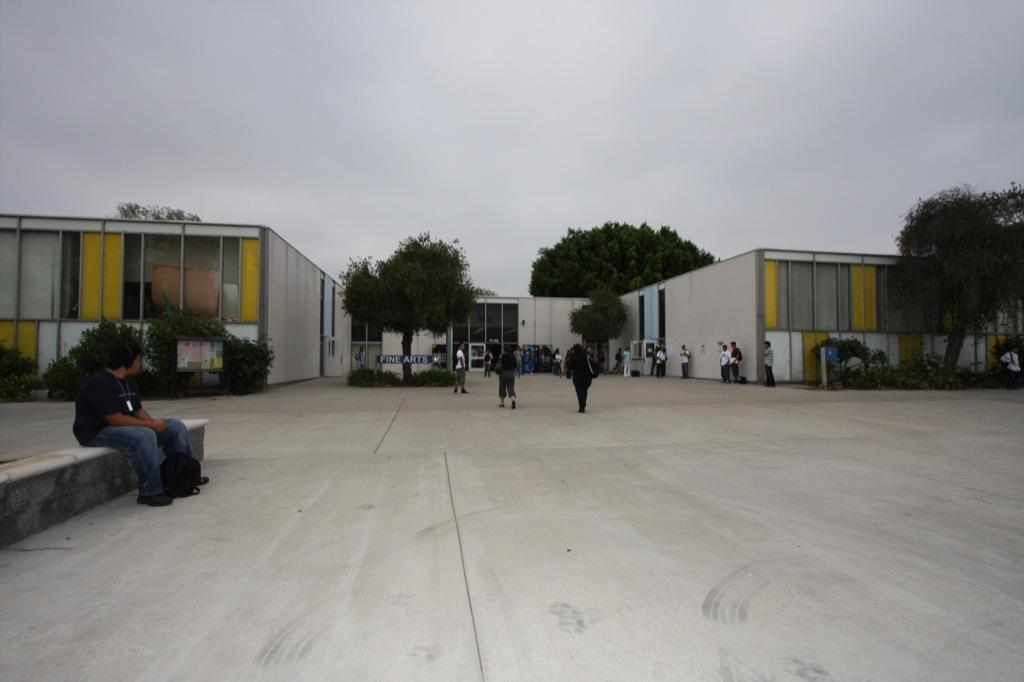What is the position of the person in the image? There is a person sitting on the left side of the image. What are the other persons in the image doing? There are persons standing and walking in the background of the image. What can be seen in the background of the image? There are buildings, trees, and a cloudy sky in the background of the image. What type of rice can be seen in the image? There is no rice present in the image. Can you tell me how many cameras are visible in the image? There are no cameras visible in the image. 